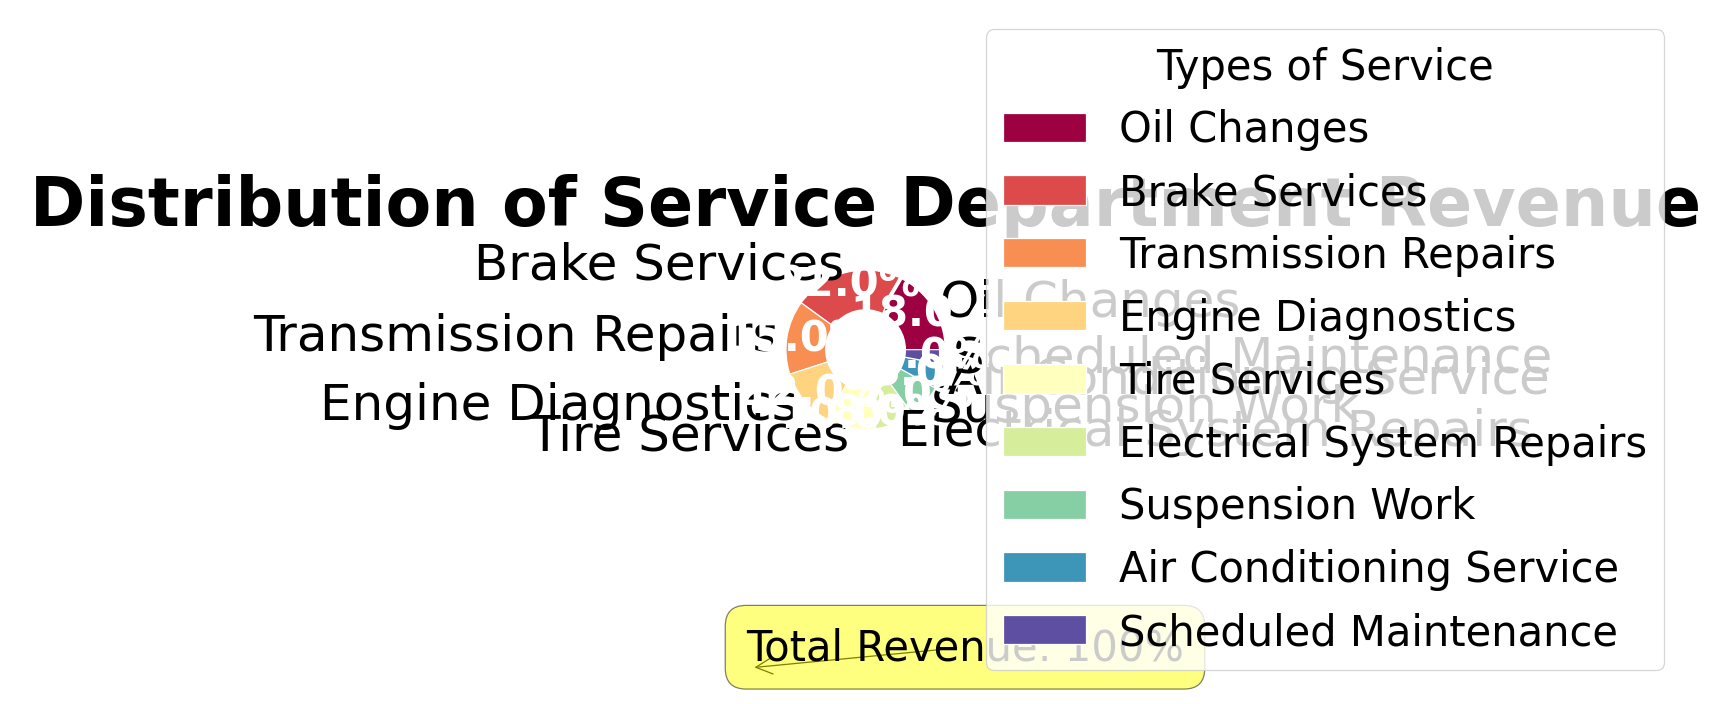What service type contributes the most to the service department's revenue? The pie chart visually shows that Brake Services have the largest wedge with 22%, indicating it is the highest contributor.
Answer: Brake Services If you combine the percentages of Oil Changes and Tire Services, what is the total percentage? According to the pie chart, Oil Changes are at 18% and Tire Services are at 10%. Adding these together gives 18% + 10% = 28%.
Answer: 28% Which service type has the smallest contribution to the total revenue? The smallest wedge in the pie chart, which is the least contributing type, is Scheduled Maintenance at 3%.
Answer: Scheduled Maintenance How much more revenue do Brake Services generate compared to Air Conditioning Service? From the pie chart, Brake Services generate 22% of the revenue whereas Air Conditioning Service generates 5%. Subtracting these gives 22% - 5% = 17%.
Answer: 17% What is the total percentage of revenue generated by Electrical System Repairs and Suspension Work together? From the pie chart, Electrical System Repairs generate 8% and Suspension Work generates 7%. Adding these together gives 8% + 7% = 15%.
Answer: 15% Is the combined revenue of Engine Diagnostics and Transmission Repairs higher than the revenue from Brake Services? Engine Diagnostics contribute 12% and Transmission Repairs contribute 15%. Adding these gives 12% + 15% = 27%, which is higher than Brake Services at 22%.
Answer: Yes Which type of service revenue is closest in percentage to Tire Services? Tire Services are at 10%. Looking at the pie chart, Electrical System Repairs, which are at 8%, are the closest in percentage.
Answer: Electrical System Repairs Rank the top three service types by revenue percentage. The pie chart shows Brake Services at 22%, Oil Changes at 18%, and Transmission Repairs at 15%. This ranks them as the top three contributors.
Answer: Brake Services, Oil Changes, Transmission Repairs What are the cumulative percentages of the top four service types? The top four service types by revenue are Brake Services (22%), Oil Changes (18%), Transmission Repairs (15%), and Engine Diagnostics (12%). Adding them together gives 22% + 18% + 15% + 12% = 67%.
Answer: 67% Do Air Conditioning Service and Scheduled Maintenance together contribute to more than 10% of the total revenue? Air Conditioning Service is 5% and Scheduled Maintenance is 3%. Adding these together gives 5% + 3% = 8%, which is less than 10%.
Answer: No 